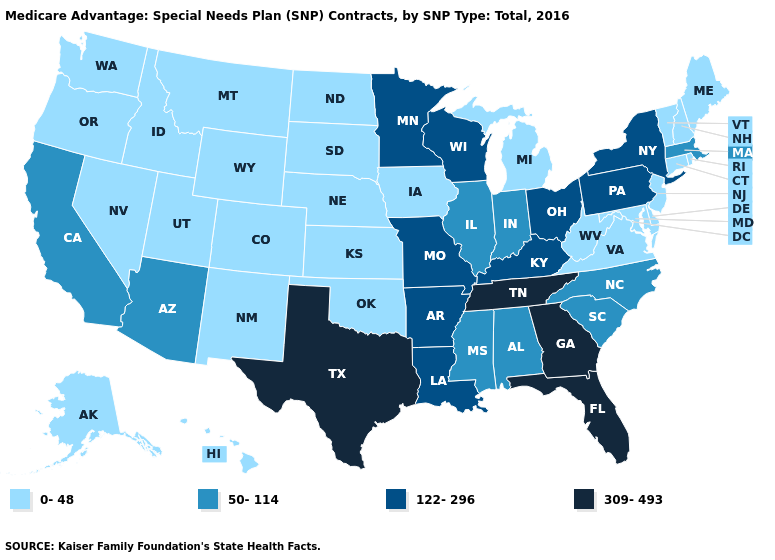Name the states that have a value in the range 309-493?
Short answer required. Florida, Georgia, Tennessee, Texas. Which states hav the highest value in the West?
Concise answer only. Arizona, California. What is the value of Connecticut?
Quick response, please. 0-48. Does Nevada have a lower value than Kentucky?
Be succinct. Yes. Does West Virginia have the same value as Maine?
Answer briefly. Yes. Is the legend a continuous bar?
Be succinct. No. Name the states that have a value in the range 309-493?
Write a very short answer. Florida, Georgia, Tennessee, Texas. Name the states that have a value in the range 309-493?
Quick response, please. Florida, Georgia, Tennessee, Texas. What is the value of South Dakota?
Write a very short answer. 0-48. What is the lowest value in states that border Nebraska?
Give a very brief answer. 0-48. Name the states that have a value in the range 50-114?
Quick response, please. Alabama, Arizona, California, Illinois, Indiana, Massachusetts, Mississippi, North Carolina, South Carolina. What is the value of North Carolina?
Give a very brief answer. 50-114. Which states have the highest value in the USA?
Keep it brief. Florida, Georgia, Tennessee, Texas. Which states have the highest value in the USA?
Short answer required. Florida, Georgia, Tennessee, Texas. What is the value of Nevada?
Answer briefly. 0-48. 